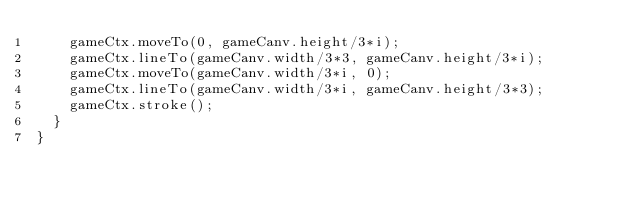Convert code to text. <code><loc_0><loc_0><loc_500><loc_500><_TypeScript_>    gameCtx.moveTo(0, gameCanv.height/3*i);
    gameCtx.lineTo(gameCanv.width/3*3, gameCanv.height/3*i);
    gameCtx.moveTo(gameCanv.width/3*i, 0);
    gameCtx.lineTo(gameCanv.width/3*i, gameCanv.height/3*3);
    gameCtx.stroke();
  }
}</code> 